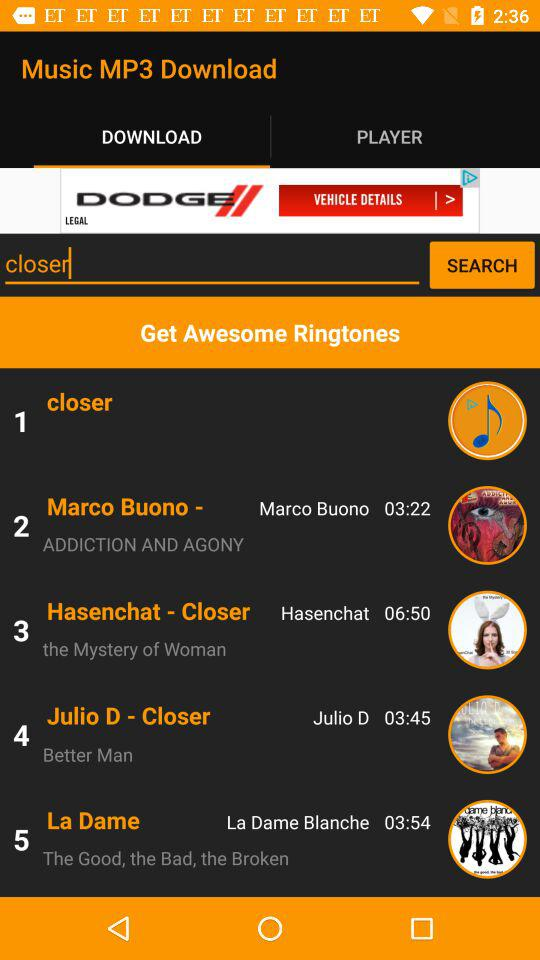What is the text input in the search bar? The text input in the search bar is "closer". 